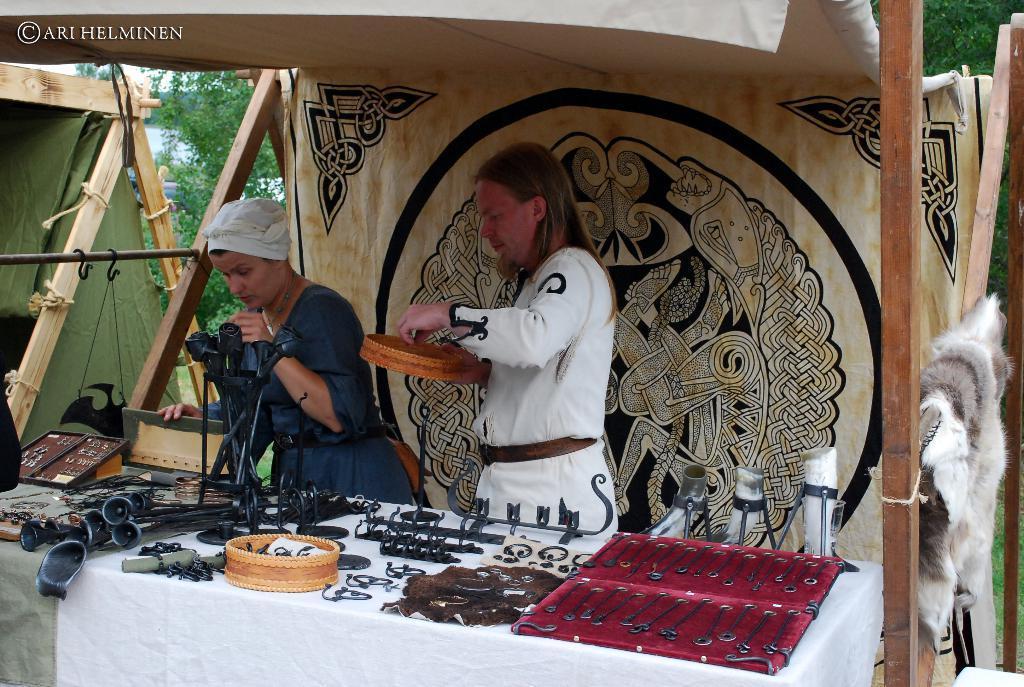Can you describe this image briefly? In this image we can see two persons inside a tent, in front of the persons there is a table, on top of the table there are few metal artifacts, in the background of the tent there are trees. 